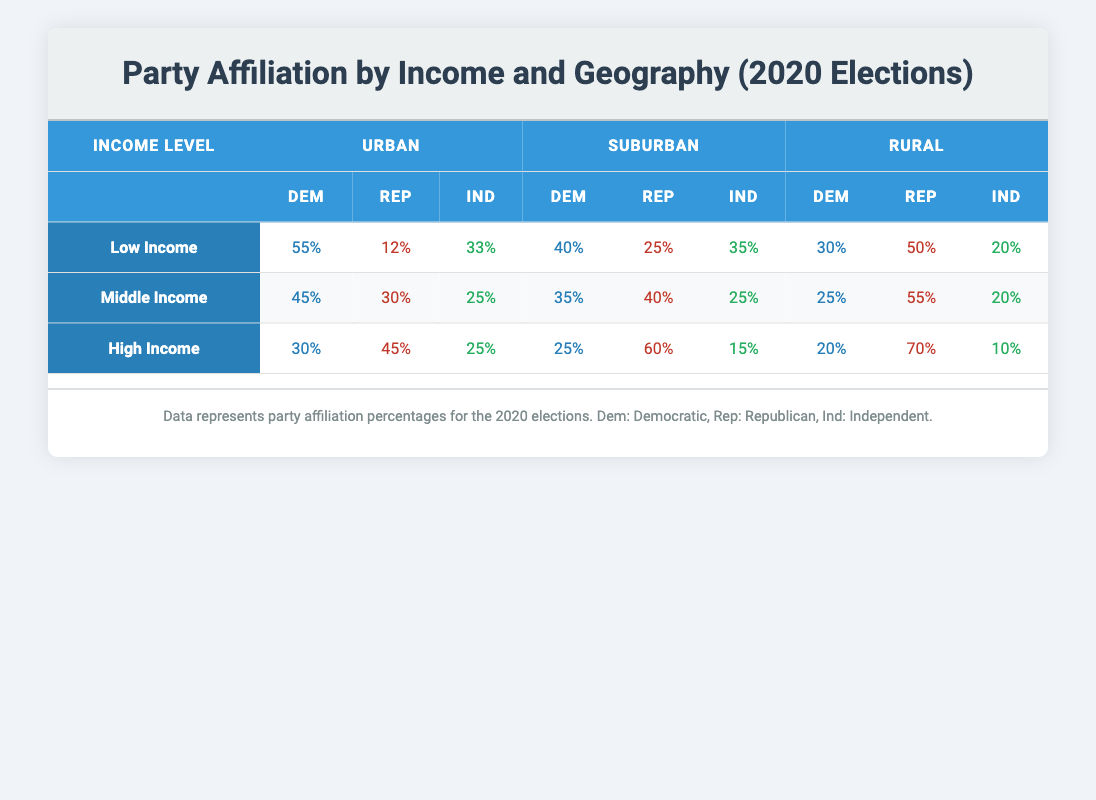What is the percentage of low-income individuals who identified as Democrats in urban areas? According to the table, in urban areas, 55% of low-income individuals identified as Democrats.
Answer: 55% What is the party affiliation of middle-income individuals living in suburban areas? In suburban areas, middle-income individuals are divided as follows: 35% Democrat, 40% Republican, and 25% Independent.
Answer: 35% Democrat, 40% Republican, 25% Independent True or False: The percentage of Republicans among high-income individuals is higher in rural areas than in urban areas. In rural areas, the percentage of Republicans is 70%, while in urban areas it is 45%. Thus, it is true that a higher percentage of Republicans among high-income individuals is in rural areas compared to urban areas.
Answer: True What is the difference in Democratic affiliation percentage between low-income individuals in urban and rural areas? In urban areas, 55% of low-income individuals are Democrats, while in rural areas, it is 30%. The difference is 55% - 30% = 25%.
Answer: 25% Which income level has the highest percentage of Republican affiliation in suburban areas? In suburban areas, high-income individuals have the highest Republican affiliation at 60%. Other income levels have 40% for low-income and 40% for middle-income.
Answer: High Income What is the average percentage of Independents across all income levels and geographic locations? For each income level, the percentages of Independents are: Low Income (33% urban, 35% suburban, 20% rural), Middle Income (25% urban, 25% suburban, 20% rural), High Income (25% urban, 15% suburban, 10% rural). Summing these gives 33 + 35 + 20 + 25 + 25 + 20 + 25 + 15 + 10 =  8 * 25 = 200, and then average is 200 / 9 ≈ 22.22%.
Answer: Approximately 22.22% What percentage of rural low-income individuals are Independents? Among low-income individuals in rural areas, the percentage that identified as Independents is 20%.
Answer: 20% What is the party affiliation of middle-income individuals who live in rural areas? In rural areas, middle-income individuals identify as follows: 25% Democrat, 55% Republican, and 20% Independent.
Answer: 25% Democrat, 55% Republican, 20% Independent 